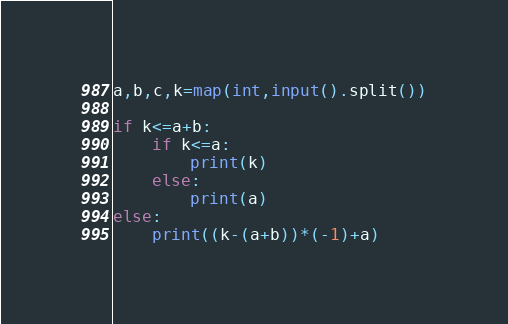Convert code to text. <code><loc_0><loc_0><loc_500><loc_500><_Python_>a,b,c,k=map(int,input().split())

if k<=a+b:
    if k<=a:
        print(k)
    else:
        print(a)
else:
    print((k-(a+b))*(-1)+a)</code> 